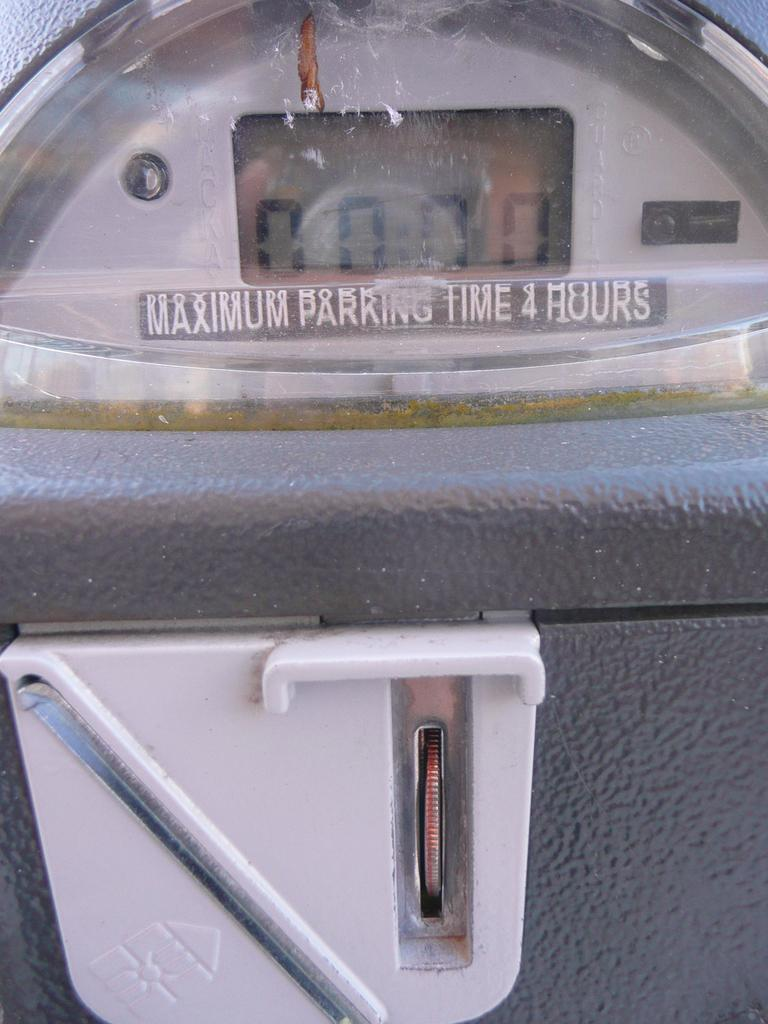<image>
Describe the image concisely. A parking meter is set to zero as a coin is being inserted. 